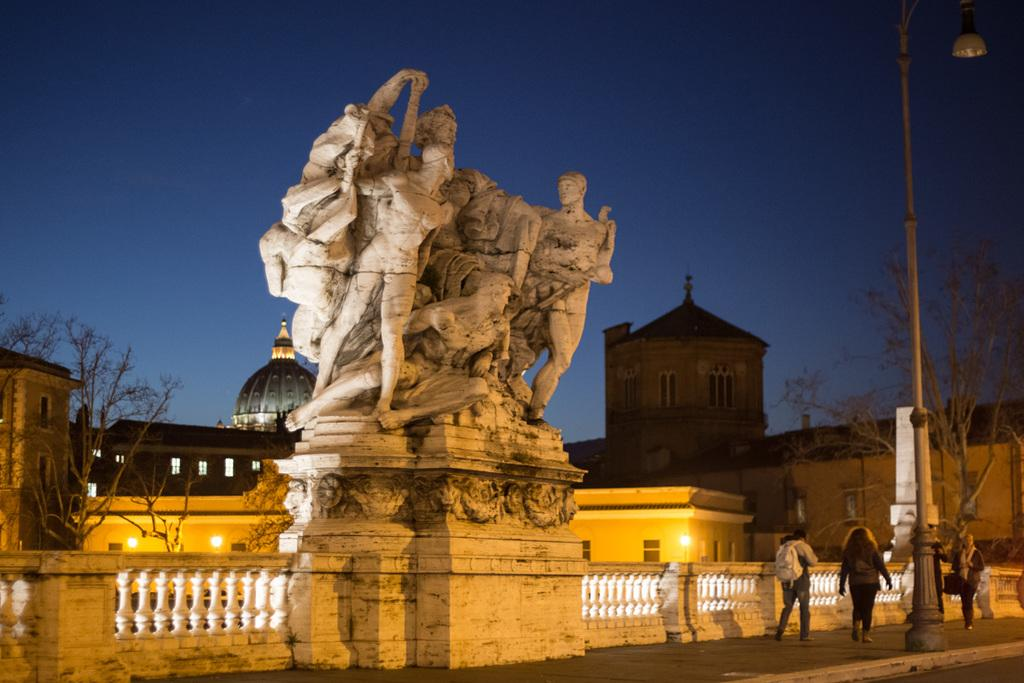What can be seen in the middle of the image? There are statues of human beings in the middle of the image. What are the people on the right side of the image doing? The people are working on the footpath on the right side of the image. What is visible at the top of the image? The sky is visible at the top of the image. What type of jewel is being used by the statues in the image? There are no jewels present in the image; it features statues of human beings. How does the behavior of the statues change throughout the day in the image? The statues are not alive and therefore do not exhibit behavior or change throughout the day in the image. 